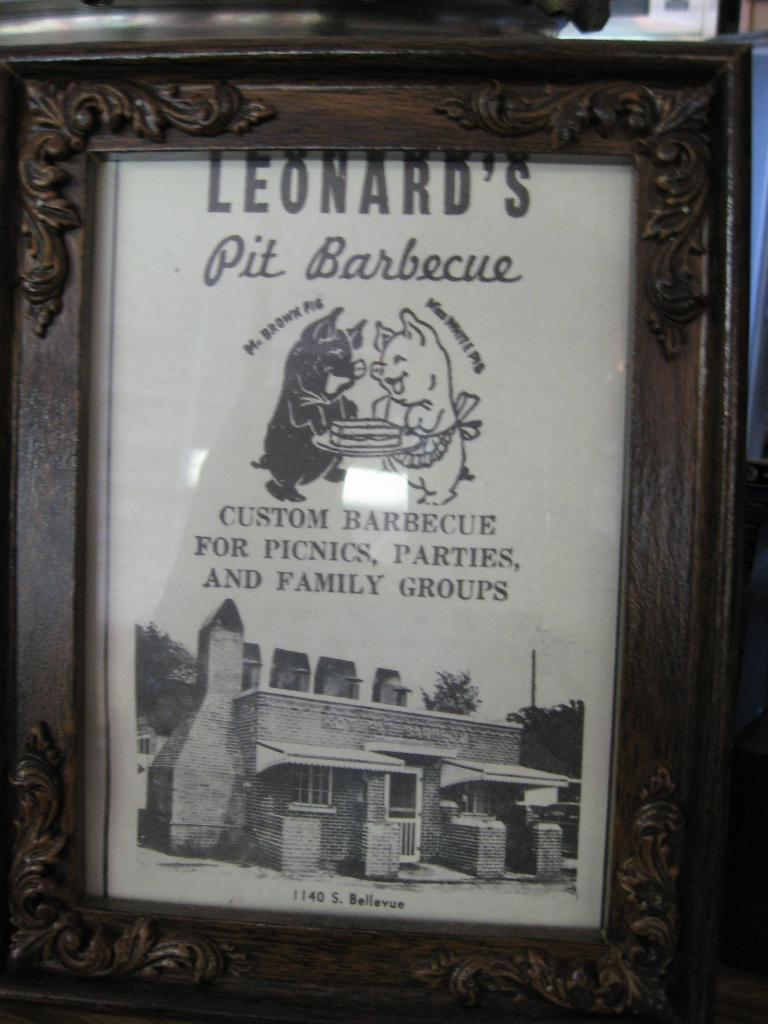What is the main subject of the image? The main subject of the image is a frame. What elements are contained within the frame? The frame contains a building, a tree, and the sky. Is there any text or writing present in the image? Yes, there is text or writing in the frame. What type of rock can be seen in the image? There is no rock present in the image; it contains a frame with a building, a tree, and the sky. Is the image hot to the touch? The image itself is not hot to the touch, as it is a visual representation and not a physical object. 